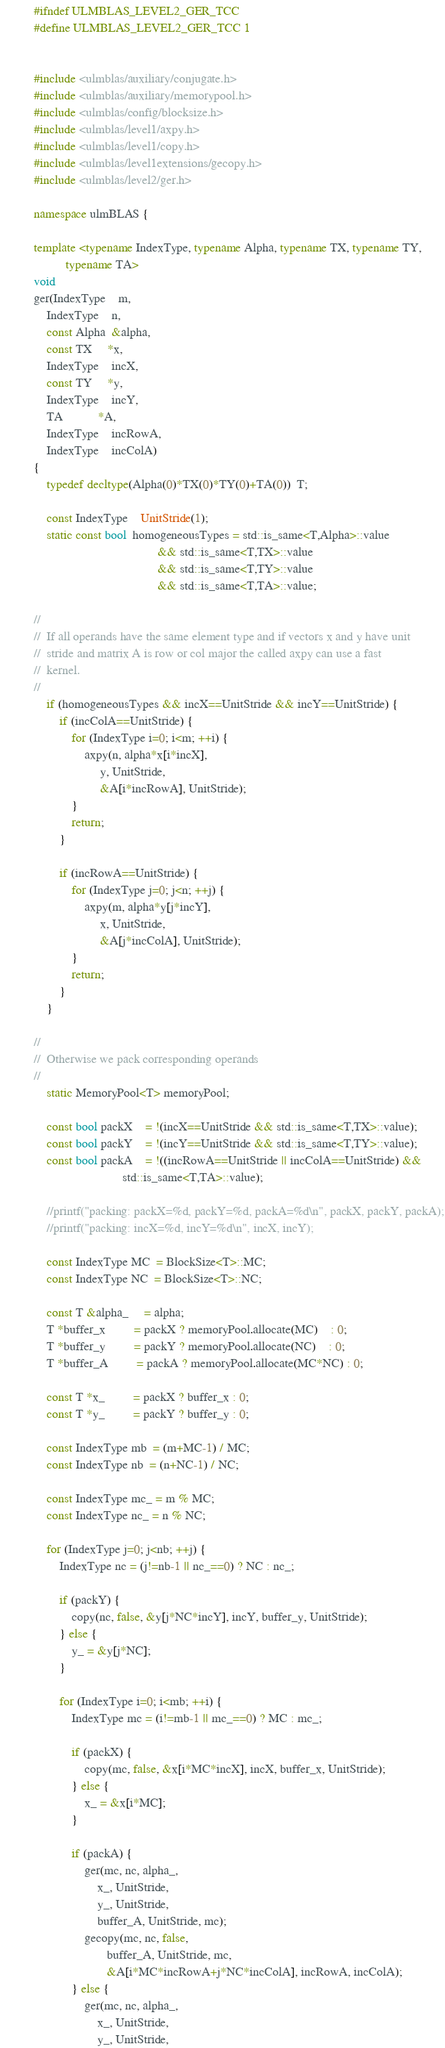Convert code to text. <code><loc_0><loc_0><loc_500><loc_500><_C++_>#ifndef ULMBLAS_LEVEL2_GER_TCC
#define ULMBLAS_LEVEL2_GER_TCC 1


#include <ulmblas/auxiliary/conjugate.h>
#include <ulmblas/auxiliary/memorypool.h>
#include <ulmblas/config/blocksize.h>
#include <ulmblas/level1/axpy.h>
#include <ulmblas/level1/copy.h>
#include <ulmblas/level1extensions/gecopy.h>
#include <ulmblas/level2/ger.h>

namespace ulmBLAS {

template <typename IndexType, typename Alpha, typename TX, typename TY,
          typename TA>
void
ger(IndexType    m,
    IndexType    n,
    const Alpha  &alpha,
    const TX     *x,
    IndexType    incX,
    const TY     *y,
    IndexType    incY,
    TA           *A,
    IndexType    incRowA,
    IndexType    incColA)
{
    typedef decltype(Alpha(0)*TX(0)*TY(0)+TA(0))  T;

    const IndexType    UnitStride(1);
    static const bool  homogeneousTypes = std::is_same<T,Alpha>::value
                                       && std::is_same<T,TX>::value
                                       && std::is_same<T,TY>::value
                                       && std::is_same<T,TA>::value;

//
//  If all operands have the same element type and if vectors x and y have unit
//  stride and matrix A is row or col major the called axpy can use a fast
//  kernel.
//
    if (homogeneousTypes && incX==UnitStride && incY==UnitStride) {
        if (incColA==UnitStride) {
            for (IndexType i=0; i<m; ++i) {
                axpy(n, alpha*x[i*incX],
                     y, UnitStride,
                     &A[i*incRowA], UnitStride);
            }
            return;
        }

        if (incRowA==UnitStride) {
            for (IndexType j=0; j<n; ++j) {
                axpy(m, alpha*y[j*incY],
                     x, UnitStride,
                     &A[j*incColA], UnitStride);
            }
            return;
        }
    }

//
//  Otherwise we pack corresponding operands
//
    static MemoryPool<T> memoryPool;

    const bool packX    = !(incX==UnitStride && std::is_same<T,TX>::value);
    const bool packY    = !(incY==UnitStride && std::is_same<T,TY>::value);
    const bool packA    = !((incRowA==UnitStride || incColA==UnitStride) &&
                            std::is_same<T,TA>::value);

    //printf("packing: packX=%d, packY=%d, packA=%d\n", packX, packY, packA);
    //printf("packing: incX=%d, incY=%d\n", incX, incY);

    const IndexType MC  = BlockSize<T>::MC;
    const IndexType NC  = BlockSize<T>::NC;

    const T &alpha_     = alpha;
    T *buffer_x         = packX ? memoryPool.allocate(MC)    : 0;
    T *buffer_y         = packY ? memoryPool.allocate(NC)    : 0;
    T *buffer_A         = packA ? memoryPool.allocate(MC*NC) : 0;

    const T *x_         = packX ? buffer_x : 0;
    const T *y_         = packY ? buffer_y : 0;

    const IndexType mb  = (m+MC-1) / MC;
    const IndexType nb  = (n+NC-1) / NC;

    const IndexType mc_ = m % MC;
    const IndexType nc_ = n % NC;

    for (IndexType j=0; j<nb; ++j) {
        IndexType nc = (j!=nb-1 || nc_==0) ? NC : nc_;

        if (packY) {
            copy(nc, false, &y[j*NC*incY], incY, buffer_y, UnitStride);
        } else {
            y_ = &y[j*NC];
        }

        for (IndexType i=0; i<mb; ++i) {
            IndexType mc = (i!=mb-1 || mc_==0) ? MC : mc_;

            if (packX) {
                copy(mc, false, &x[i*MC*incX], incX, buffer_x, UnitStride);
            } else {
                x_ = &x[i*MC];
            }

            if (packA) {
                ger(mc, nc, alpha_,
                    x_, UnitStride,
                    y_, UnitStride,
                    buffer_A, UnitStride, mc);
                gecopy(mc, nc, false,
                       buffer_A, UnitStride, mc,
                       &A[i*MC*incRowA+j*NC*incColA], incRowA, incColA);
            } else {
                ger(mc, nc, alpha_,
                    x_, UnitStride,
                    y_, UnitStride,</code> 